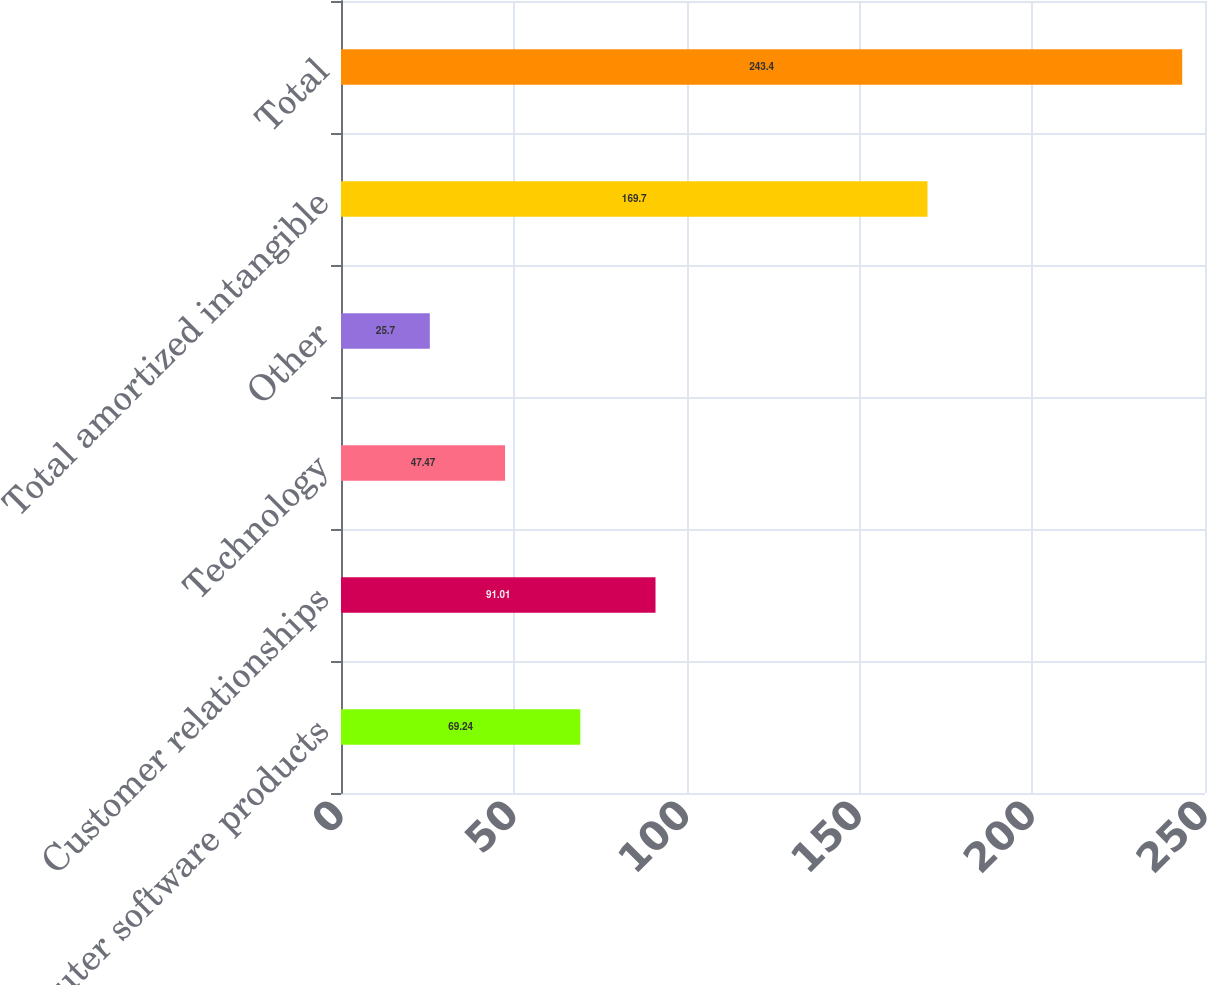Convert chart. <chart><loc_0><loc_0><loc_500><loc_500><bar_chart><fcel>Computer software products<fcel>Customer relationships<fcel>Technology<fcel>Other<fcel>Total amortized intangible<fcel>Total<nl><fcel>69.24<fcel>91.01<fcel>47.47<fcel>25.7<fcel>169.7<fcel>243.4<nl></chart> 